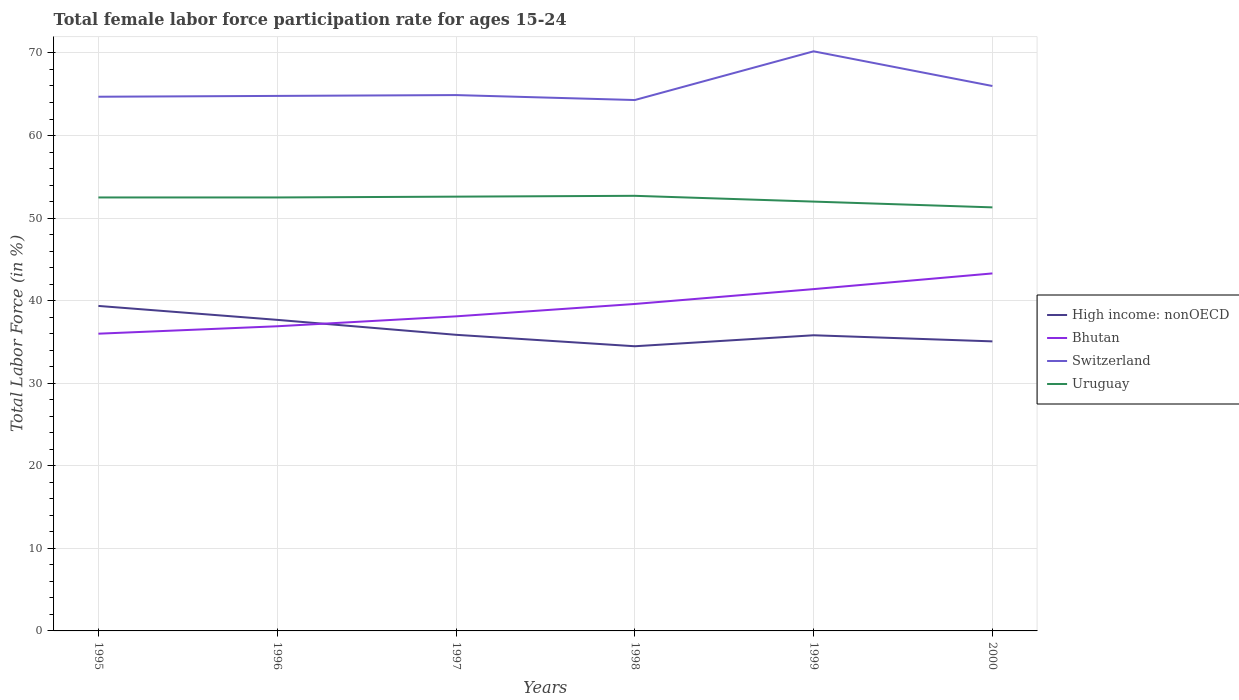Does the line corresponding to High income: nonOECD intersect with the line corresponding to Switzerland?
Your answer should be very brief. No. Is the number of lines equal to the number of legend labels?
Keep it short and to the point. Yes. Across all years, what is the maximum female labor force participation rate in High income: nonOECD?
Offer a terse response. 34.48. What is the total female labor force participation rate in Switzerland in the graph?
Ensure brevity in your answer.  0.6. What is the difference between the highest and the second highest female labor force participation rate in Uruguay?
Offer a terse response. 1.4. What is the difference between the highest and the lowest female labor force participation rate in Uruguay?
Make the answer very short. 4. How many lines are there?
Offer a very short reply. 4. How many years are there in the graph?
Your answer should be compact. 6. What is the difference between two consecutive major ticks on the Y-axis?
Your answer should be very brief. 10. Does the graph contain any zero values?
Make the answer very short. No. How many legend labels are there?
Your answer should be very brief. 4. How are the legend labels stacked?
Offer a terse response. Vertical. What is the title of the graph?
Your answer should be very brief. Total female labor force participation rate for ages 15-24. Does "Madagascar" appear as one of the legend labels in the graph?
Your answer should be compact. No. What is the Total Labor Force (in %) in High income: nonOECD in 1995?
Make the answer very short. 39.36. What is the Total Labor Force (in %) in Switzerland in 1995?
Offer a terse response. 64.7. What is the Total Labor Force (in %) in Uruguay in 1995?
Your answer should be compact. 52.5. What is the Total Labor Force (in %) of High income: nonOECD in 1996?
Give a very brief answer. 37.68. What is the Total Labor Force (in %) of Bhutan in 1996?
Your answer should be very brief. 36.9. What is the Total Labor Force (in %) of Switzerland in 1996?
Keep it short and to the point. 64.8. What is the Total Labor Force (in %) in Uruguay in 1996?
Give a very brief answer. 52.5. What is the Total Labor Force (in %) of High income: nonOECD in 1997?
Offer a terse response. 35.87. What is the Total Labor Force (in %) in Bhutan in 1997?
Your response must be concise. 38.1. What is the Total Labor Force (in %) of Switzerland in 1997?
Provide a short and direct response. 64.9. What is the Total Labor Force (in %) of Uruguay in 1997?
Provide a succinct answer. 52.6. What is the Total Labor Force (in %) of High income: nonOECD in 1998?
Ensure brevity in your answer.  34.48. What is the Total Labor Force (in %) of Bhutan in 1998?
Your answer should be compact. 39.6. What is the Total Labor Force (in %) of Switzerland in 1998?
Your response must be concise. 64.3. What is the Total Labor Force (in %) of Uruguay in 1998?
Offer a very short reply. 52.7. What is the Total Labor Force (in %) of High income: nonOECD in 1999?
Offer a very short reply. 35.81. What is the Total Labor Force (in %) of Bhutan in 1999?
Offer a very short reply. 41.4. What is the Total Labor Force (in %) of Switzerland in 1999?
Give a very brief answer. 70.2. What is the Total Labor Force (in %) in Uruguay in 1999?
Your answer should be compact. 52. What is the Total Labor Force (in %) in High income: nonOECD in 2000?
Offer a very short reply. 35.07. What is the Total Labor Force (in %) in Bhutan in 2000?
Your answer should be compact. 43.3. What is the Total Labor Force (in %) in Switzerland in 2000?
Make the answer very short. 66. What is the Total Labor Force (in %) in Uruguay in 2000?
Make the answer very short. 51.3. Across all years, what is the maximum Total Labor Force (in %) in High income: nonOECD?
Keep it short and to the point. 39.36. Across all years, what is the maximum Total Labor Force (in %) of Bhutan?
Provide a succinct answer. 43.3. Across all years, what is the maximum Total Labor Force (in %) in Switzerland?
Your answer should be very brief. 70.2. Across all years, what is the maximum Total Labor Force (in %) of Uruguay?
Provide a short and direct response. 52.7. Across all years, what is the minimum Total Labor Force (in %) of High income: nonOECD?
Offer a terse response. 34.48. Across all years, what is the minimum Total Labor Force (in %) in Switzerland?
Make the answer very short. 64.3. Across all years, what is the minimum Total Labor Force (in %) of Uruguay?
Your answer should be very brief. 51.3. What is the total Total Labor Force (in %) of High income: nonOECD in the graph?
Your response must be concise. 218.26. What is the total Total Labor Force (in %) of Bhutan in the graph?
Your answer should be very brief. 235.3. What is the total Total Labor Force (in %) of Switzerland in the graph?
Your response must be concise. 394.9. What is the total Total Labor Force (in %) in Uruguay in the graph?
Ensure brevity in your answer.  313.6. What is the difference between the Total Labor Force (in %) in High income: nonOECD in 1995 and that in 1996?
Your answer should be compact. 1.69. What is the difference between the Total Labor Force (in %) in Switzerland in 1995 and that in 1996?
Your response must be concise. -0.1. What is the difference between the Total Labor Force (in %) in Uruguay in 1995 and that in 1996?
Keep it short and to the point. 0. What is the difference between the Total Labor Force (in %) in High income: nonOECD in 1995 and that in 1997?
Your answer should be very brief. 3.5. What is the difference between the Total Labor Force (in %) in Bhutan in 1995 and that in 1997?
Give a very brief answer. -2.1. What is the difference between the Total Labor Force (in %) in Switzerland in 1995 and that in 1997?
Ensure brevity in your answer.  -0.2. What is the difference between the Total Labor Force (in %) in High income: nonOECD in 1995 and that in 1998?
Offer a terse response. 4.88. What is the difference between the Total Labor Force (in %) of Bhutan in 1995 and that in 1998?
Your answer should be compact. -3.6. What is the difference between the Total Labor Force (in %) of Switzerland in 1995 and that in 1998?
Your answer should be very brief. 0.4. What is the difference between the Total Labor Force (in %) in High income: nonOECD in 1995 and that in 1999?
Your answer should be compact. 3.55. What is the difference between the Total Labor Force (in %) in Bhutan in 1995 and that in 1999?
Ensure brevity in your answer.  -5.4. What is the difference between the Total Labor Force (in %) of Uruguay in 1995 and that in 1999?
Offer a terse response. 0.5. What is the difference between the Total Labor Force (in %) of High income: nonOECD in 1995 and that in 2000?
Your answer should be very brief. 4.29. What is the difference between the Total Labor Force (in %) of Uruguay in 1995 and that in 2000?
Offer a terse response. 1.2. What is the difference between the Total Labor Force (in %) of High income: nonOECD in 1996 and that in 1997?
Your answer should be compact. 1.81. What is the difference between the Total Labor Force (in %) in Bhutan in 1996 and that in 1997?
Ensure brevity in your answer.  -1.2. What is the difference between the Total Labor Force (in %) of Switzerland in 1996 and that in 1997?
Your answer should be compact. -0.1. What is the difference between the Total Labor Force (in %) in Uruguay in 1996 and that in 1997?
Give a very brief answer. -0.1. What is the difference between the Total Labor Force (in %) of High income: nonOECD in 1996 and that in 1998?
Provide a succinct answer. 3.2. What is the difference between the Total Labor Force (in %) of Bhutan in 1996 and that in 1998?
Your response must be concise. -2.7. What is the difference between the Total Labor Force (in %) in Switzerland in 1996 and that in 1998?
Offer a very short reply. 0.5. What is the difference between the Total Labor Force (in %) of Uruguay in 1996 and that in 1998?
Give a very brief answer. -0.2. What is the difference between the Total Labor Force (in %) in High income: nonOECD in 1996 and that in 1999?
Provide a short and direct response. 1.87. What is the difference between the Total Labor Force (in %) of Bhutan in 1996 and that in 1999?
Provide a succinct answer. -4.5. What is the difference between the Total Labor Force (in %) in Switzerland in 1996 and that in 1999?
Offer a terse response. -5.4. What is the difference between the Total Labor Force (in %) in High income: nonOECD in 1996 and that in 2000?
Your answer should be compact. 2.61. What is the difference between the Total Labor Force (in %) in Switzerland in 1996 and that in 2000?
Give a very brief answer. -1.2. What is the difference between the Total Labor Force (in %) of Uruguay in 1996 and that in 2000?
Your answer should be very brief. 1.2. What is the difference between the Total Labor Force (in %) of High income: nonOECD in 1997 and that in 1998?
Make the answer very short. 1.39. What is the difference between the Total Labor Force (in %) in Bhutan in 1997 and that in 1998?
Provide a short and direct response. -1.5. What is the difference between the Total Labor Force (in %) of Switzerland in 1997 and that in 1998?
Provide a short and direct response. 0.6. What is the difference between the Total Labor Force (in %) of High income: nonOECD in 1997 and that in 1999?
Provide a short and direct response. 0.06. What is the difference between the Total Labor Force (in %) of Bhutan in 1997 and that in 1999?
Make the answer very short. -3.3. What is the difference between the Total Labor Force (in %) of Switzerland in 1997 and that in 1999?
Give a very brief answer. -5.3. What is the difference between the Total Labor Force (in %) in Uruguay in 1997 and that in 1999?
Your response must be concise. 0.6. What is the difference between the Total Labor Force (in %) of High income: nonOECD in 1997 and that in 2000?
Offer a terse response. 0.8. What is the difference between the Total Labor Force (in %) of Bhutan in 1997 and that in 2000?
Offer a very short reply. -5.2. What is the difference between the Total Labor Force (in %) of Switzerland in 1997 and that in 2000?
Offer a terse response. -1.1. What is the difference between the Total Labor Force (in %) of High income: nonOECD in 1998 and that in 1999?
Provide a succinct answer. -1.33. What is the difference between the Total Labor Force (in %) of Switzerland in 1998 and that in 1999?
Provide a succinct answer. -5.9. What is the difference between the Total Labor Force (in %) in High income: nonOECD in 1998 and that in 2000?
Your answer should be very brief. -0.59. What is the difference between the Total Labor Force (in %) in Switzerland in 1998 and that in 2000?
Provide a succinct answer. -1.7. What is the difference between the Total Labor Force (in %) in Uruguay in 1998 and that in 2000?
Give a very brief answer. 1.4. What is the difference between the Total Labor Force (in %) in High income: nonOECD in 1999 and that in 2000?
Keep it short and to the point. 0.74. What is the difference between the Total Labor Force (in %) of Bhutan in 1999 and that in 2000?
Give a very brief answer. -1.9. What is the difference between the Total Labor Force (in %) in Switzerland in 1999 and that in 2000?
Offer a very short reply. 4.2. What is the difference between the Total Labor Force (in %) of High income: nonOECD in 1995 and the Total Labor Force (in %) of Bhutan in 1996?
Give a very brief answer. 2.46. What is the difference between the Total Labor Force (in %) in High income: nonOECD in 1995 and the Total Labor Force (in %) in Switzerland in 1996?
Offer a very short reply. -25.44. What is the difference between the Total Labor Force (in %) in High income: nonOECD in 1995 and the Total Labor Force (in %) in Uruguay in 1996?
Offer a terse response. -13.14. What is the difference between the Total Labor Force (in %) of Bhutan in 1995 and the Total Labor Force (in %) of Switzerland in 1996?
Provide a short and direct response. -28.8. What is the difference between the Total Labor Force (in %) in Bhutan in 1995 and the Total Labor Force (in %) in Uruguay in 1996?
Offer a terse response. -16.5. What is the difference between the Total Labor Force (in %) in Switzerland in 1995 and the Total Labor Force (in %) in Uruguay in 1996?
Keep it short and to the point. 12.2. What is the difference between the Total Labor Force (in %) in High income: nonOECD in 1995 and the Total Labor Force (in %) in Bhutan in 1997?
Make the answer very short. 1.26. What is the difference between the Total Labor Force (in %) in High income: nonOECD in 1995 and the Total Labor Force (in %) in Switzerland in 1997?
Ensure brevity in your answer.  -25.54. What is the difference between the Total Labor Force (in %) in High income: nonOECD in 1995 and the Total Labor Force (in %) in Uruguay in 1997?
Your response must be concise. -13.24. What is the difference between the Total Labor Force (in %) in Bhutan in 1995 and the Total Labor Force (in %) in Switzerland in 1997?
Offer a very short reply. -28.9. What is the difference between the Total Labor Force (in %) in Bhutan in 1995 and the Total Labor Force (in %) in Uruguay in 1997?
Offer a terse response. -16.6. What is the difference between the Total Labor Force (in %) of High income: nonOECD in 1995 and the Total Labor Force (in %) of Bhutan in 1998?
Offer a terse response. -0.24. What is the difference between the Total Labor Force (in %) of High income: nonOECD in 1995 and the Total Labor Force (in %) of Switzerland in 1998?
Make the answer very short. -24.94. What is the difference between the Total Labor Force (in %) in High income: nonOECD in 1995 and the Total Labor Force (in %) in Uruguay in 1998?
Your answer should be very brief. -13.34. What is the difference between the Total Labor Force (in %) of Bhutan in 1995 and the Total Labor Force (in %) of Switzerland in 1998?
Give a very brief answer. -28.3. What is the difference between the Total Labor Force (in %) of Bhutan in 1995 and the Total Labor Force (in %) of Uruguay in 1998?
Offer a very short reply. -16.7. What is the difference between the Total Labor Force (in %) of Switzerland in 1995 and the Total Labor Force (in %) of Uruguay in 1998?
Provide a succinct answer. 12. What is the difference between the Total Labor Force (in %) in High income: nonOECD in 1995 and the Total Labor Force (in %) in Bhutan in 1999?
Your answer should be compact. -2.04. What is the difference between the Total Labor Force (in %) of High income: nonOECD in 1995 and the Total Labor Force (in %) of Switzerland in 1999?
Ensure brevity in your answer.  -30.84. What is the difference between the Total Labor Force (in %) of High income: nonOECD in 1995 and the Total Labor Force (in %) of Uruguay in 1999?
Give a very brief answer. -12.64. What is the difference between the Total Labor Force (in %) in Bhutan in 1995 and the Total Labor Force (in %) in Switzerland in 1999?
Your response must be concise. -34.2. What is the difference between the Total Labor Force (in %) of Bhutan in 1995 and the Total Labor Force (in %) of Uruguay in 1999?
Your response must be concise. -16. What is the difference between the Total Labor Force (in %) of Switzerland in 1995 and the Total Labor Force (in %) of Uruguay in 1999?
Keep it short and to the point. 12.7. What is the difference between the Total Labor Force (in %) in High income: nonOECD in 1995 and the Total Labor Force (in %) in Bhutan in 2000?
Make the answer very short. -3.94. What is the difference between the Total Labor Force (in %) in High income: nonOECD in 1995 and the Total Labor Force (in %) in Switzerland in 2000?
Offer a terse response. -26.64. What is the difference between the Total Labor Force (in %) in High income: nonOECD in 1995 and the Total Labor Force (in %) in Uruguay in 2000?
Your response must be concise. -11.94. What is the difference between the Total Labor Force (in %) of Bhutan in 1995 and the Total Labor Force (in %) of Switzerland in 2000?
Offer a very short reply. -30. What is the difference between the Total Labor Force (in %) of Bhutan in 1995 and the Total Labor Force (in %) of Uruguay in 2000?
Offer a terse response. -15.3. What is the difference between the Total Labor Force (in %) of High income: nonOECD in 1996 and the Total Labor Force (in %) of Bhutan in 1997?
Ensure brevity in your answer.  -0.42. What is the difference between the Total Labor Force (in %) of High income: nonOECD in 1996 and the Total Labor Force (in %) of Switzerland in 1997?
Offer a terse response. -27.23. What is the difference between the Total Labor Force (in %) in High income: nonOECD in 1996 and the Total Labor Force (in %) in Uruguay in 1997?
Provide a short and direct response. -14.93. What is the difference between the Total Labor Force (in %) of Bhutan in 1996 and the Total Labor Force (in %) of Switzerland in 1997?
Provide a short and direct response. -28. What is the difference between the Total Labor Force (in %) in Bhutan in 1996 and the Total Labor Force (in %) in Uruguay in 1997?
Your answer should be very brief. -15.7. What is the difference between the Total Labor Force (in %) of High income: nonOECD in 1996 and the Total Labor Force (in %) of Bhutan in 1998?
Provide a short and direct response. -1.93. What is the difference between the Total Labor Force (in %) of High income: nonOECD in 1996 and the Total Labor Force (in %) of Switzerland in 1998?
Your answer should be very brief. -26.62. What is the difference between the Total Labor Force (in %) in High income: nonOECD in 1996 and the Total Labor Force (in %) in Uruguay in 1998?
Offer a terse response. -15.03. What is the difference between the Total Labor Force (in %) of Bhutan in 1996 and the Total Labor Force (in %) of Switzerland in 1998?
Offer a terse response. -27.4. What is the difference between the Total Labor Force (in %) in Bhutan in 1996 and the Total Labor Force (in %) in Uruguay in 1998?
Provide a succinct answer. -15.8. What is the difference between the Total Labor Force (in %) of Switzerland in 1996 and the Total Labor Force (in %) of Uruguay in 1998?
Provide a short and direct response. 12.1. What is the difference between the Total Labor Force (in %) in High income: nonOECD in 1996 and the Total Labor Force (in %) in Bhutan in 1999?
Offer a very short reply. -3.73. What is the difference between the Total Labor Force (in %) of High income: nonOECD in 1996 and the Total Labor Force (in %) of Switzerland in 1999?
Provide a succinct answer. -32.52. What is the difference between the Total Labor Force (in %) of High income: nonOECD in 1996 and the Total Labor Force (in %) of Uruguay in 1999?
Ensure brevity in your answer.  -14.32. What is the difference between the Total Labor Force (in %) of Bhutan in 1996 and the Total Labor Force (in %) of Switzerland in 1999?
Make the answer very short. -33.3. What is the difference between the Total Labor Force (in %) of Bhutan in 1996 and the Total Labor Force (in %) of Uruguay in 1999?
Give a very brief answer. -15.1. What is the difference between the Total Labor Force (in %) in Switzerland in 1996 and the Total Labor Force (in %) in Uruguay in 1999?
Your answer should be very brief. 12.8. What is the difference between the Total Labor Force (in %) of High income: nonOECD in 1996 and the Total Labor Force (in %) of Bhutan in 2000?
Give a very brief answer. -5.62. What is the difference between the Total Labor Force (in %) in High income: nonOECD in 1996 and the Total Labor Force (in %) in Switzerland in 2000?
Provide a short and direct response. -28.32. What is the difference between the Total Labor Force (in %) in High income: nonOECD in 1996 and the Total Labor Force (in %) in Uruguay in 2000?
Provide a short and direct response. -13.62. What is the difference between the Total Labor Force (in %) in Bhutan in 1996 and the Total Labor Force (in %) in Switzerland in 2000?
Provide a short and direct response. -29.1. What is the difference between the Total Labor Force (in %) in Bhutan in 1996 and the Total Labor Force (in %) in Uruguay in 2000?
Keep it short and to the point. -14.4. What is the difference between the Total Labor Force (in %) in High income: nonOECD in 1997 and the Total Labor Force (in %) in Bhutan in 1998?
Provide a short and direct response. -3.73. What is the difference between the Total Labor Force (in %) in High income: nonOECD in 1997 and the Total Labor Force (in %) in Switzerland in 1998?
Your response must be concise. -28.43. What is the difference between the Total Labor Force (in %) in High income: nonOECD in 1997 and the Total Labor Force (in %) in Uruguay in 1998?
Make the answer very short. -16.83. What is the difference between the Total Labor Force (in %) of Bhutan in 1997 and the Total Labor Force (in %) of Switzerland in 1998?
Provide a short and direct response. -26.2. What is the difference between the Total Labor Force (in %) of Bhutan in 1997 and the Total Labor Force (in %) of Uruguay in 1998?
Ensure brevity in your answer.  -14.6. What is the difference between the Total Labor Force (in %) of High income: nonOECD in 1997 and the Total Labor Force (in %) of Bhutan in 1999?
Your answer should be compact. -5.53. What is the difference between the Total Labor Force (in %) in High income: nonOECD in 1997 and the Total Labor Force (in %) in Switzerland in 1999?
Provide a short and direct response. -34.33. What is the difference between the Total Labor Force (in %) of High income: nonOECD in 1997 and the Total Labor Force (in %) of Uruguay in 1999?
Keep it short and to the point. -16.13. What is the difference between the Total Labor Force (in %) in Bhutan in 1997 and the Total Labor Force (in %) in Switzerland in 1999?
Provide a short and direct response. -32.1. What is the difference between the Total Labor Force (in %) of Bhutan in 1997 and the Total Labor Force (in %) of Uruguay in 1999?
Ensure brevity in your answer.  -13.9. What is the difference between the Total Labor Force (in %) of High income: nonOECD in 1997 and the Total Labor Force (in %) of Bhutan in 2000?
Your response must be concise. -7.43. What is the difference between the Total Labor Force (in %) in High income: nonOECD in 1997 and the Total Labor Force (in %) in Switzerland in 2000?
Your answer should be compact. -30.13. What is the difference between the Total Labor Force (in %) of High income: nonOECD in 1997 and the Total Labor Force (in %) of Uruguay in 2000?
Make the answer very short. -15.43. What is the difference between the Total Labor Force (in %) in Bhutan in 1997 and the Total Labor Force (in %) in Switzerland in 2000?
Offer a very short reply. -27.9. What is the difference between the Total Labor Force (in %) of Bhutan in 1997 and the Total Labor Force (in %) of Uruguay in 2000?
Ensure brevity in your answer.  -13.2. What is the difference between the Total Labor Force (in %) in Switzerland in 1997 and the Total Labor Force (in %) in Uruguay in 2000?
Keep it short and to the point. 13.6. What is the difference between the Total Labor Force (in %) in High income: nonOECD in 1998 and the Total Labor Force (in %) in Bhutan in 1999?
Your response must be concise. -6.92. What is the difference between the Total Labor Force (in %) of High income: nonOECD in 1998 and the Total Labor Force (in %) of Switzerland in 1999?
Your answer should be very brief. -35.72. What is the difference between the Total Labor Force (in %) in High income: nonOECD in 1998 and the Total Labor Force (in %) in Uruguay in 1999?
Offer a very short reply. -17.52. What is the difference between the Total Labor Force (in %) of Bhutan in 1998 and the Total Labor Force (in %) of Switzerland in 1999?
Provide a short and direct response. -30.6. What is the difference between the Total Labor Force (in %) in High income: nonOECD in 1998 and the Total Labor Force (in %) in Bhutan in 2000?
Ensure brevity in your answer.  -8.82. What is the difference between the Total Labor Force (in %) in High income: nonOECD in 1998 and the Total Labor Force (in %) in Switzerland in 2000?
Make the answer very short. -31.52. What is the difference between the Total Labor Force (in %) of High income: nonOECD in 1998 and the Total Labor Force (in %) of Uruguay in 2000?
Provide a succinct answer. -16.82. What is the difference between the Total Labor Force (in %) in Bhutan in 1998 and the Total Labor Force (in %) in Switzerland in 2000?
Your answer should be very brief. -26.4. What is the difference between the Total Labor Force (in %) of Bhutan in 1998 and the Total Labor Force (in %) of Uruguay in 2000?
Give a very brief answer. -11.7. What is the difference between the Total Labor Force (in %) of Switzerland in 1998 and the Total Labor Force (in %) of Uruguay in 2000?
Provide a succinct answer. 13. What is the difference between the Total Labor Force (in %) of High income: nonOECD in 1999 and the Total Labor Force (in %) of Bhutan in 2000?
Make the answer very short. -7.49. What is the difference between the Total Labor Force (in %) in High income: nonOECD in 1999 and the Total Labor Force (in %) in Switzerland in 2000?
Your answer should be very brief. -30.19. What is the difference between the Total Labor Force (in %) of High income: nonOECD in 1999 and the Total Labor Force (in %) of Uruguay in 2000?
Offer a terse response. -15.49. What is the difference between the Total Labor Force (in %) in Bhutan in 1999 and the Total Labor Force (in %) in Switzerland in 2000?
Your answer should be very brief. -24.6. What is the average Total Labor Force (in %) in High income: nonOECD per year?
Give a very brief answer. 36.38. What is the average Total Labor Force (in %) of Bhutan per year?
Ensure brevity in your answer.  39.22. What is the average Total Labor Force (in %) of Switzerland per year?
Give a very brief answer. 65.82. What is the average Total Labor Force (in %) of Uruguay per year?
Your answer should be compact. 52.27. In the year 1995, what is the difference between the Total Labor Force (in %) of High income: nonOECD and Total Labor Force (in %) of Bhutan?
Your response must be concise. 3.36. In the year 1995, what is the difference between the Total Labor Force (in %) in High income: nonOECD and Total Labor Force (in %) in Switzerland?
Provide a succinct answer. -25.34. In the year 1995, what is the difference between the Total Labor Force (in %) of High income: nonOECD and Total Labor Force (in %) of Uruguay?
Offer a very short reply. -13.14. In the year 1995, what is the difference between the Total Labor Force (in %) of Bhutan and Total Labor Force (in %) of Switzerland?
Offer a very short reply. -28.7. In the year 1995, what is the difference between the Total Labor Force (in %) of Bhutan and Total Labor Force (in %) of Uruguay?
Provide a succinct answer. -16.5. In the year 1995, what is the difference between the Total Labor Force (in %) in Switzerland and Total Labor Force (in %) in Uruguay?
Ensure brevity in your answer.  12.2. In the year 1996, what is the difference between the Total Labor Force (in %) of High income: nonOECD and Total Labor Force (in %) of Bhutan?
Your response must be concise. 0.78. In the year 1996, what is the difference between the Total Labor Force (in %) of High income: nonOECD and Total Labor Force (in %) of Switzerland?
Your answer should be very brief. -27.12. In the year 1996, what is the difference between the Total Labor Force (in %) in High income: nonOECD and Total Labor Force (in %) in Uruguay?
Offer a terse response. -14.82. In the year 1996, what is the difference between the Total Labor Force (in %) of Bhutan and Total Labor Force (in %) of Switzerland?
Your response must be concise. -27.9. In the year 1996, what is the difference between the Total Labor Force (in %) of Bhutan and Total Labor Force (in %) of Uruguay?
Your response must be concise. -15.6. In the year 1996, what is the difference between the Total Labor Force (in %) of Switzerland and Total Labor Force (in %) of Uruguay?
Provide a short and direct response. 12.3. In the year 1997, what is the difference between the Total Labor Force (in %) in High income: nonOECD and Total Labor Force (in %) in Bhutan?
Give a very brief answer. -2.23. In the year 1997, what is the difference between the Total Labor Force (in %) of High income: nonOECD and Total Labor Force (in %) of Switzerland?
Your answer should be compact. -29.03. In the year 1997, what is the difference between the Total Labor Force (in %) of High income: nonOECD and Total Labor Force (in %) of Uruguay?
Offer a very short reply. -16.73. In the year 1997, what is the difference between the Total Labor Force (in %) in Bhutan and Total Labor Force (in %) in Switzerland?
Your answer should be very brief. -26.8. In the year 1997, what is the difference between the Total Labor Force (in %) in Bhutan and Total Labor Force (in %) in Uruguay?
Ensure brevity in your answer.  -14.5. In the year 1997, what is the difference between the Total Labor Force (in %) of Switzerland and Total Labor Force (in %) of Uruguay?
Make the answer very short. 12.3. In the year 1998, what is the difference between the Total Labor Force (in %) in High income: nonOECD and Total Labor Force (in %) in Bhutan?
Make the answer very short. -5.12. In the year 1998, what is the difference between the Total Labor Force (in %) in High income: nonOECD and Total Labor Force (in %) in Switzerland?
Offer a very short reply. -29.82. In the year 1998, what is the difference between the Total Labor Force (in %) in High income: nonOECD and Total Labor Force (in %) in Uruguay?
Your response must be concise. -18.22. In the year 1998, what is the difference between the Total Labor Force (in %) in Bhutan and Total Labor Force (in %) in Switzerland?
Your response must be concise. -24.7. In the year 1998, what is the difference between the Total Labor Force (in %) in Switzerland and Total Labor Force (in %) in Uruguay?
Ensure brevity in your answer.  11.6. In the year 1999, what is the difference between the Total Labor Force (in %) in High income: nonOECD and Total Labor Force (in %) in Bhutan?
Offer a terse response. -5.59. In the year 1999, what is the difference between the Total Labor Force (in %) in High income: nonOECD and Total Labor Force (in %) in Switzerland?
Provide a short and direct response. -34.39. In the year 1999, what is the difference between the Total Labor Force (in %) in High income: nonOECD and Total Labor Force (in %) in Uruguay?
Make the answer very short. -16.19. In the year 1999, what is the difference between the Total Labor Force (in %) of Bhutan and Total Labor Force (in %) of Switzerland?
Your response must be concise. -28.8. In the year 2000, what is the difference between the Total Labor Force (in %) in High income: nonOECD and Total Labor Force (in %) in Bhutan?
Give a very brief answer. -8.23. In the year 2000, what is the difference between the Total Labor Force (in %) in High income: nonOECD and Total Labor Force (in %) in Switzerland?
Provide a succinct answer. -30.93. In the year 2000, what is the difference between the Total Labor Force (in %) in High income: nonOECD and Total Labor Force (in %) in Uruguay?
Your answer should be very brief. -16.23. In the year 2000, what is the difference between the Total Labor Force (in %) in Bhutan and Total Labor Force (in %) in Switzerland?
Offer a terse response. -22.7. In the year 2000, what is the difference between the Total Labor Force (in %) of Switzerland and Total Labor Force (in %) of Uruguay?
Provide a succinct answer. 14.7. What is the ratio of the Total Labor Force (in %) of High income: nonOECD in 1995 to that in 1996?
Keep it short and to the point. 1.04. What is the ratio of the Total Labor Force (in %) of Bhutan in 1995 to that in 1996?
Offer a terse response. 0.98. What is the ratio of the Total Labor Force (in %) in High income: nonOECD in 1995 to that in 1997?
Give a very brief answer. 1.1. What is the ratio of the Total Labor Force (in %) in Bhutan in 1995 to that in 1997?
Your response must be concise. 0.94. What is the ratio of the Total Labor Force (in %) of High income: nonOECD in 1995 to that in 1998?
Offer a terse response. 1.14. What is the ratio of the Total Labor Force (in %) of Bhutan in 1995 to that in 1998?
Give a very brief answer. 0.91. What is the ratio of the Total Labor Force (in %) of Switzerland in 1995 to that in 1998?
Your response must be concise. 1.01. What is the ratio of the Total Labor Force (in %) of High income: nonOECD in 1995 to that in 1999?
Make the answer very short. 1.1. What is the ratio of the Total Labor Force (in %) of Bhutan in 1995 to that in 1999?
Your answer should be very brief. 0.87. What is the ratio of the Total Labor Force (in %) of Switzerland in 1995 to that in 1999?
Your answer should be very brief. 0.92. What is the ratio of the Total Labor Force (in %) in Uruguay in 1995 to that in 1999?
Make the answer very short. 1.01. What is the ratio of the Total Labor Force (in %) of High income: nonOECD in 1995 to that in 2000?
Offer a terse response. 1.12. What is the ratio of the Total Labor Force (in %) of Bhutan in 1995 to that in 2000?
Your answer should be compact. 0.83. What is the ratio of the Total Labor Force (in %) in Switzerland in 1995 to that in 2000?
Offer a very short reply. 0.98. What is the ratio of the Total Labor Force (in %) in Uruguay in 1995 to that in 2000?
Ensure brevity in your answer.  1.02. What is the ratio of the Total Labor Force (in %) of High income: nonOECD in 1996 to that in 1997?
Your answer should be compact. 1.05. What is the ratio of the Total Labor Force (in %) of Bhutan in 1996 to that in 1997?
Provide a short and direct response. 0.97. What is the ratio of the Total Labor Force (in %) in Switzerland in 1996 to that in 1997?
Give a very brief answer. 1. What is the ratio of the Total Labor Force (in %) in Uruguay in 1996 to that in 1997?
Your answer should be compact. 1. What is the ratio of the Total Labor Force (in %) of High income: nonOECD in 1996 to that in 1998?
Your answer should be compact. 1.09. What is the ratio of the Total Labor Force (in %) of Bhutan in 1996 to that in 1998?
Your answer should be compact. 0.93. What is the ratio of the Total Labor Force (in %) in High income: nonOECD in 1996 to that in 1999?
Keep it short and to the point. 1.05. What is the ratio of the Total Labor Force (in %) in Bhutan in 1996 to that in 1999?
Your response must be concise. 0.89. What is the ratio of the Total Labor Force (in %) in Uruguay in 1996 to that in 1999?
Make the answer very short. 1.01. What is the ratio of the Total Labor Force (in %) of High income: nonOECD in 1996 to that in 2000?
Keep it short and to the point. 1.07. What is the ratio of the Total Labor Force (in %) in Bhutan in 1996 to that in 2000?
Give a very brief answer. 0.85. What is the ratio of the Total Labor Force (in %) in Switzerland in 1996 to that in 2000?
Provide a succinct answer. 0.98. What is the ratio of the Total Labor Force (in %) in Uruguay in 1996 to that in 2000?
Provide a short and direct response. 1.02. What is the ratio of the Total Labor Force (in %) in High income: nonOECD in 1997 to that in 1998?
Offer a terse response. 1.04. What is the ratio of the Total Labor Force (in %) of Bhutan in 1997 to that in 1998?
Offer a terse response. 0.96. What is the ratio of the Total Labor Force (in %) in Switzerland in 1997 to that in 1998?
Provide a succinct answer. 1.01. What is the ratio of the Total Labor Force (in %) in Uruguay in 1997 to that in 1998?
Your answer should be very brief. 1. What is the ratio of the Total Labor Force (in %) in Bhutan in 1997 to that in 1999?
Provide a succinct answer. 0.92. What is the ratio of the Total Labor Force (in %) in Switzerland in 1997 to that in 1999?
Make the answer very short. 0.92. What is the ratio of the Total Labor Force (in %) of Uruguay in 1997 to that in 1999?
Your answer should be compact. 1.01. What is the ratio of the Total Labor Force (in %) of High income: nonOECD in 1997 to that in 2000?
Provide a short and direct response. 1.02. What is the ratio of the Total Labor Force (in %) in Bhutan in 1997 to that in 2000?
Provide a succinct answer. 0.88. What is the ratio of the Total Labor Force (in %) in Switzerland in 1997 to that in 2000?
Provide a succinct answer. 0.98. What is the ratio of the Total Labor Force (in %) in Uruguay in 1997 to that in 2000?
Give a very brief answer. 1.03. What is the ratio of the Total Labor Force (in %) of High income: nonOECD in 1998 to that in 1999?
Offer a very short reply. 0.96. What is the ratio of the Total Labor Force (in %) of Bhutan in 1998 to that in 1999?
Your answer should be compact. 0.96. What is the ratio of the Total Labor Force (in %) in Switzerland in 1998 to that in 1999?
Offer a very short reply. 0.92. What is the ratio of the Total Labor Force (in %) in Uruguay in 1998 to that in 1999?
Provide a short and direct response. 1.01. What is the ratio of the Total Labor Force (in %) in High income: nonOECD in 1998 to that in 2000?
Give a very brief answer. 0.98. What is the ratio of the Total Labor Force (in %) in Bhutan in 1998 to that in 2000?
Make the answer very short. 0.91. What is the ratio of the Total Labor Force (in %) of Switzerland in 1998 to that in 2000?
Your response must be concise. 0.97. What is the ratio of the Total Labor Force (in %) in Uruguay in 1998 to that in 2000?
Make the answer very short. 1.03. What is the ratio of the Total Labor Force (in %) in High income: nonOECD in 1999 to that in 2000?
Keep it short and to the point. 1.02. What is the ratio of the Total Labor Force (in %) of Bhutan in 1999 to that in 2000?
Keep it short and to the point. 0.96. What is the ratio of the Total Labor Force (in %) in Switzerland in 1999 to that in 2000?
Give a very brief answer. 1.06. What is the ratio of the Total Labor Force (in %) in Uruguay in 1999 to that in 2000?
Your answer should be very brief. 1.01. What is the difference between the highest and the second highest Total Labor Force (in %) in High income: nonOECD?
Your answer should be very brief. 1.69. What is the difference between the highest and the second highest Total Labor Force (in %) of Switzerland?
Offer a terse response. 4.2. What is the difference between the highest and the lowest Total Labor Force (in %) in High income: nonOECD?
Give a very brief answer. 4.88. What is the difference between the highest and the lowest Total Labor Force (in %) in Bhutan?
Your answer should be compact. 7.3. What is the difference between the highest and the lowest Total Labor Force (in %) in Uruguay?
Offer a very short reply. 1.4. 